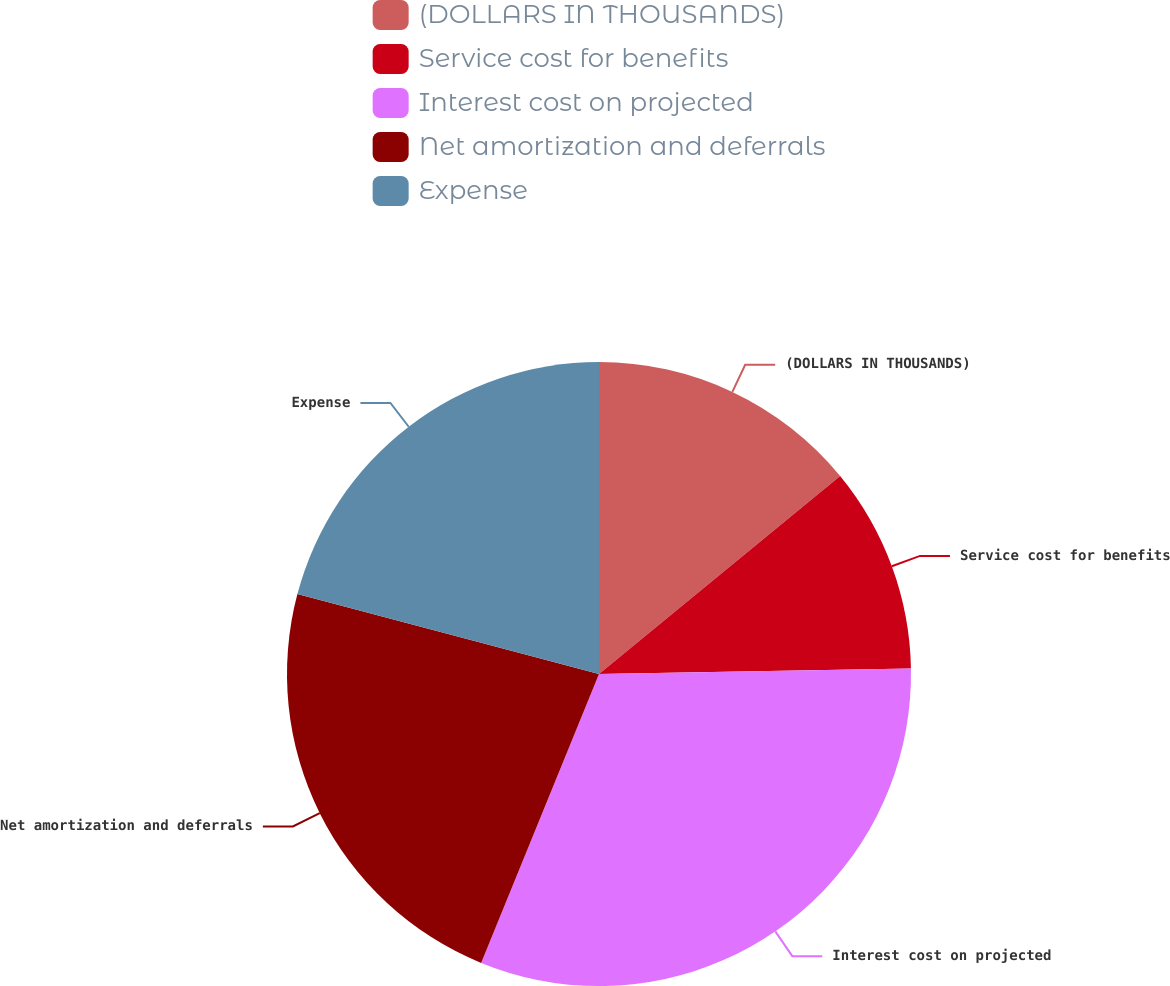<chart> <loc_0><loc_0><loc_500><loc_500><pie_chart><fcel>(DOLLARS IN THOUSANDS)<fcel>Service cost for benefits<fcel>Interest cost on projected<fcel>Net amortization and deferrals<fcel>Expense<nl><fcel>14.06%<fcel>10.66%<fcel>31.45%<fcel>22.96%<fcel>20.88%<nl></chart> 